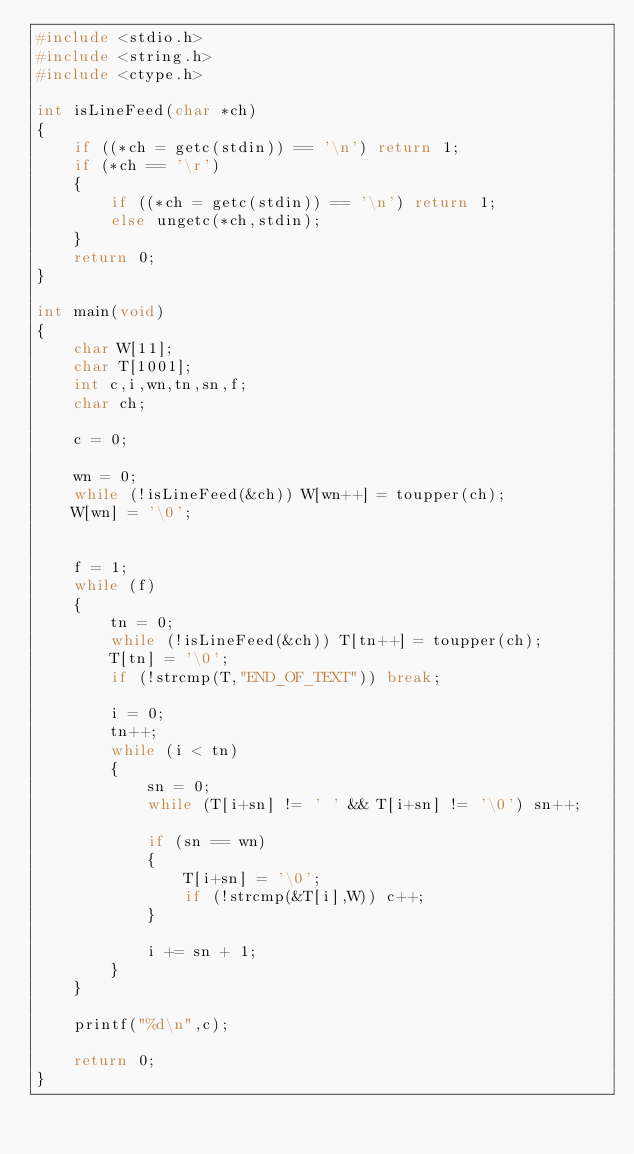Convert code to text. <code><loc_0><loc_0><loc_500><loc_500><_C_>#include <stdio.h>
#include <string.h>
#include <ctype.h>

int isLineFeed(char *ch)
{
	if ((*ch = getc(stdin)) == '\n') return 1;
	if (*ch == '\r')
	{
		if ((*ch = getc(stdin)) == '\n') return 1;
		else ungetc(*ch,stdin);
	}
	return 0;
}

int main(void)
{
	char W[11];
	char T[1001];
	int c,i,wn,tn,sn,f;
	char ch;

	c = 0;

	wn = 0;
	while (!isLineFeed(&ch)) W[wn++] = toupper(ch);
	W[wn] = '\0';
	

	f = 1;
	while (f)
	{
		tn = 0;
		while (!isLineFeed(&ch)) T[tn++] = toupper(ch);
		T[tn] = '\0';
		if (!strcmp(T,"END_OF_TEXT")) break;

		i = 0;
		tn++;
		while (i < tn)
		{
			sn = 0;
			while (T[i+sn] != ' ' && T[i+sn] != '\0') sn++;

			if (sn == wn)
			{
				T[i+sn] = '\0';
				if (!strcmp(&T[i],W)) c++;
			}

			i += sn + 1;
		}
	}

	printf("%d\n",c);

	return 0;
}</code> 